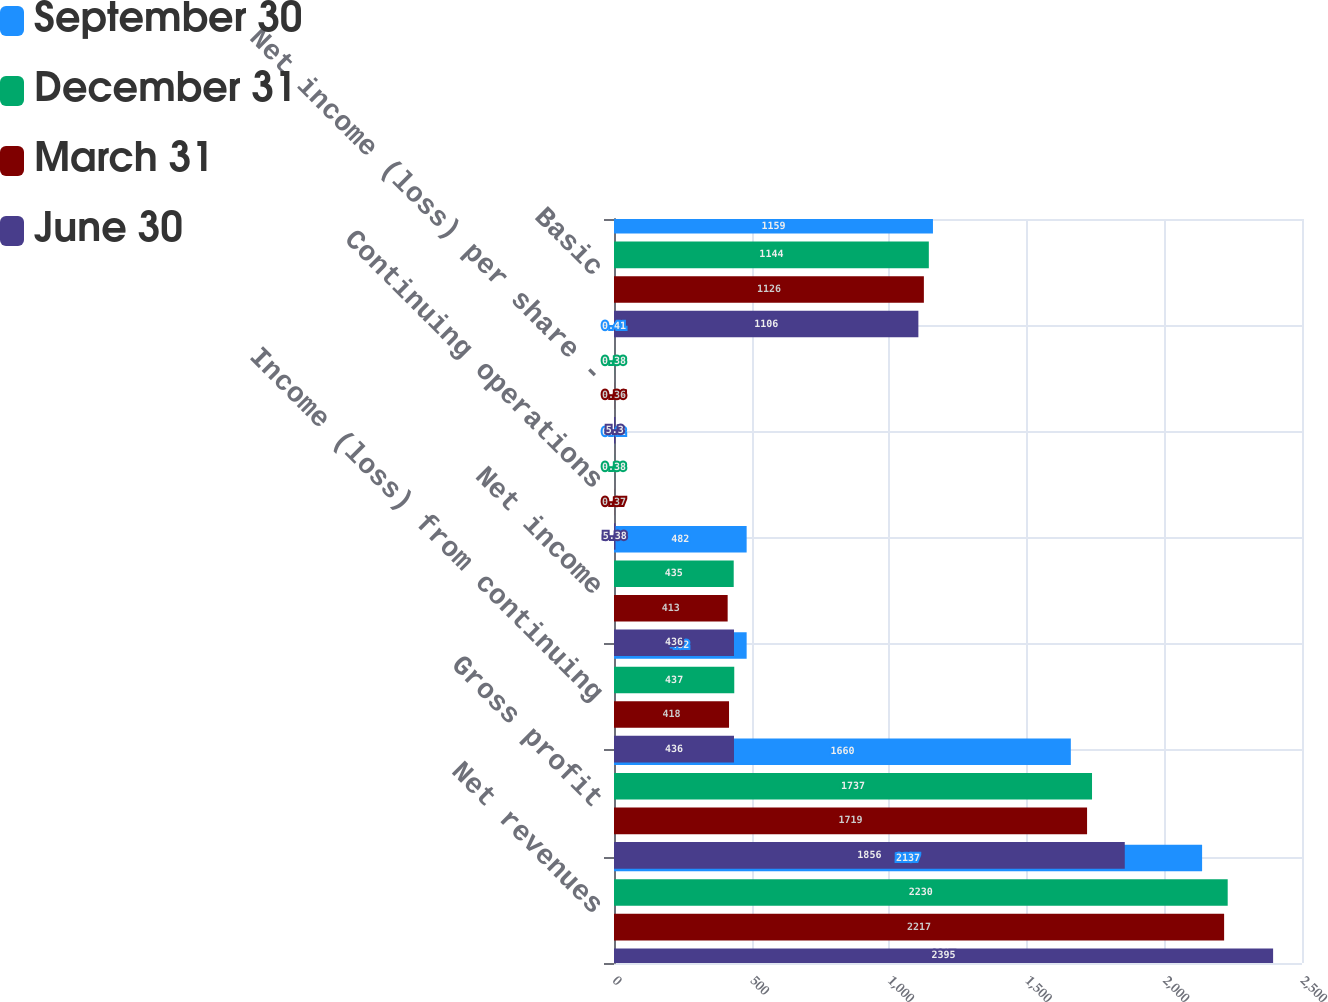<chart> <loc_0><loc_0><loc_500><loc_500><stacked_bar_chart><ecel><fcel>Net revenues<fcel>Gross profit<fcel>Income (loss) from continuing<fcel>Net income<fcel>Continuing operations<fcel>Net income (loss) per share -<fcel>Basic<nl><fcel>September 30<fcel>2137<fcel>1660<fcel>482<fcel>482<fcel>0.42<fcel>0.41<fcel>1159<nl><fcel>December 31<fcel>2230<fcel>1737<fcel>437<fcel>435<fcel>0.38<fcel>0.38<fcel>1144<nl><fcel>March 31<fcel>2217<fcel>1719<fcel>418<fcel>413<fcel>0.37<fcel>0.36<fcel>1126<nl><fcel>June 30<fcel>2395<fcel>1856<fcel>436<fcel>436<fcel>5.38<fcel>5.3<fcel>1106<nl></chart> 